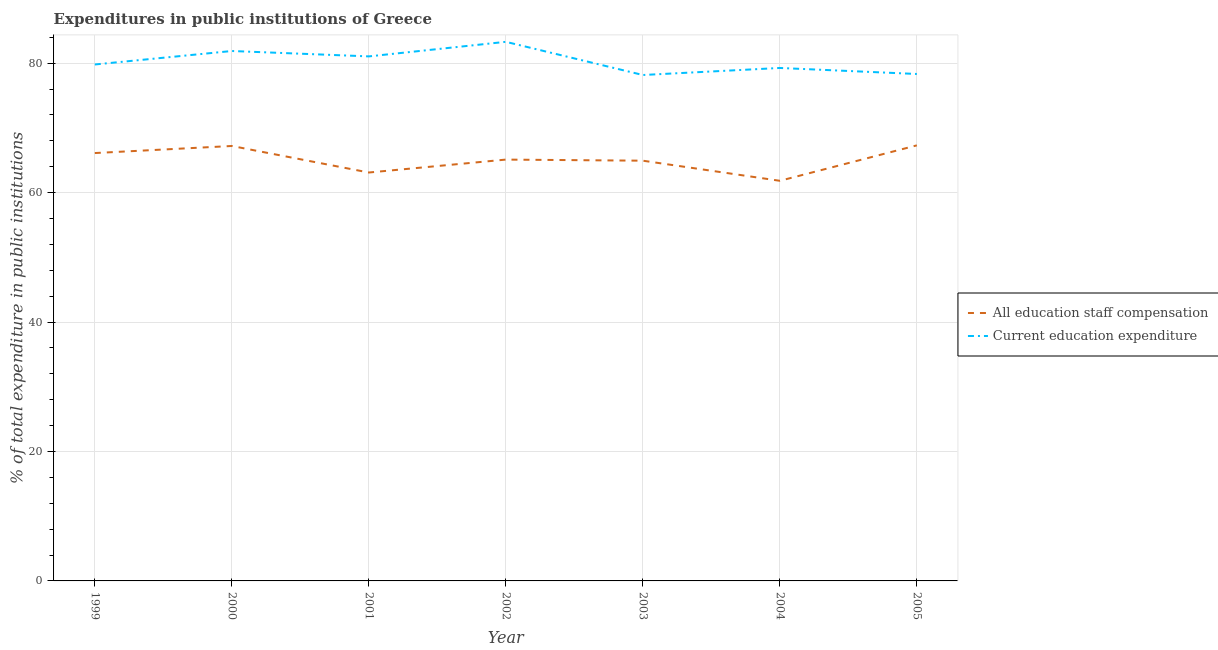Does the line corresponding to expenditure in staff compensation intersect with the line corresponding to expenditure in education?
Provide a short and direct response. No. What is the expenditure in education in 1999?
Ensure brevity in your answer.  79.79. Across all years, what is the maximum expenditure in staff compensation?
Provide a short and direct response. 67.29. Across all years, what is the minimum expenditure in education?
Your answer should be very brief. 78.16. In which year was the expenditure in staff compensation maximum?
Offer a very short reply. 2005. In which year was the expenditure in staff compensation minimum?
Offer a very short reply. 2004. What is the total expenditure in staff compensation in the graph?
Provide a short and direct response. 455.54. What is the difference between the expenditure in education in 2002 and that in 2004?
Offer a very short reply. 4.04. What is the difference between the expenditure in education in 2004 and the expenditure in staff compensation in 2005?
Ensure brevity in your answer.  11.96. What is the average expenditure in education per year?
Keep it short and to the point. 80.25. In the year 2000, what is the difference between the expenditure in education and expenditure in staff compensation?
Your response must be concise. 14.67. In how many years, is the expenditure in staff compensation greater than 64 %?
Make the answer very short. 5. What is the ratio of the expenditure in staff compensation in 1999 to that in 2002?
Your answer should be very brief. 1.02. Is the expenditure in education in 1999 less than that in 2004?
Your answer should be compact. No. What is the difference between the highest and the second highest expenditure in education?
Provide a succinct answer. 1.42. What is the difference between the highest and the lowest expenditure in staff compensation?
Ensure brevity in your answer.  5.48. Is the expenditure in staff compensation strictly greater than the expenditure in education over the years?
Make the answer very short. No. How many lines are there?
Your response must be concise. 2. How many years are there in the graph?
Provide a succinct answer. 7. Are the values on the major ticks of Y-axis written in scientific E-notation?
Your answer should be compact. No. Where does the legend appear in the graph?
Ensure brevity in your answer.  Center right. What is the title of the graph?
Provide a succinct answer. Expenditures in public institutions of Greece. What is the label or title of the Y-axis?
Your answer should be compact. % of total expenditure in public institutions. What is the % of total expenditure in public institutions in All education staff compensation in 1999?
Offer a very short reply. 66.11. What is the % of total expenditure in public institutions in Current education expenditure in 1999?
Give a very brief answer. 79.79. What is the % of total expenditure in public institutions in All education staff compensation in 2000?
Your response must be concise. 67.2. What is the % of total expenditure in public institutions of Current education expenditure in 2000?
Offer a terse response. 81.87. What is the % of total expenditure in public institutions of All education staff compensation in 2001?
Give a very brief answer. 63.1. What is the % of total expenditure in public institutions in Current education expenditure in 2001?
Make the answer very short. 81.04. What is the % of total expenditure in public institutions of All education staff compensation in 2002?
Provide a succinct answer. 65.1. What is the % of total expenditure in public institutions of Current education expenditure in 2002?
Provide a succinct answer. 83.29. What is the % of total expenditure in public institutions in All education staff compensation in 2003?
Give a very brief answer. 64.93. What is the % of total expenditure in public institutions in Current education expenditure in 2003?
Provide a succinct answer. 78.16. What is the % of total expenditure in public institutions of All education staff compensation in 2004?
Your answer should be very brief. 61.82. What is the % of total expenditure in public institutions of Current education expenditure in 2004?
Offer a very short reply. 79.25. What is the % of total expenditure in public institutions in All education staff compensation in 2005?
Offer a terse response. 67.29. What is the % of total expenditure in public institutions in Current education expenditure in 2005?
Provide a succinct answer. 78.32. Across all years, what is the maximum % of total expenditure in public institutions of All education staff compensation?
Your answer should be very brief. 67.29. Across all years, what is the maximum % of total expenditure in public institutions of Current education expenditure?
Keep it short and to the point. 83.29. Across all years, what is the minimum % of total expenditure in public institutions in All education staff compensation?
Keep it short and to the point. 61.82. Across all years, what is the minimum % of total expenditure in public institutions in Current education expenditure?
Ensure brevity in your answer.  78.16. What is the total % of total expenditure in public institutions in All education staff compensation in the graph?
Make the answer very short. 455.54. What is the total % of total expenditure in public institutions in Current education expenditure in the graph?
Your answer should be compact. 561.73. What is the difference between the % of total expenditure in public institutions of All education staff compensation in 1999 and that in 2000?
Offer a very short reply. -1.09. What is the difference between the % of total expenditure in public institutions of Current education expenditure in 1999 and that in 2000?
Provide a short and direct response. -2.08. What is the difference between the % of total expenditure in public institutions in All education staff compensation in 1999 and that in 2001?
Ensure brevity in your answer.  3.01. What is the difference between the % of total expenditure in public institutions in Current education expenditure in 1999 and that in 2001?
Keep it short and to the point. -1.25. What is the difference between the % of total expenditure in public institutions of All education staff compensation in 1999 and that in 2002?
Offer a terse response. 1.01. What is the difference between the % of total expenditure in public institutions in Current education expenditure in 1999 and that in 2002?
Offer a very short reply. -3.5. What is the difference between the % of total expenditure in public institutions in All education staff compensation in 1999 and that in 2003?
Ensure brevity in your answer.  1.18. What is the difference between the % of total expenditure in public institutions of Current education expenditure in 1999 and that in 2003?
Your response must be concise. 1.63. What is the difference between the % of total expenditure in public institutions in All education staff compensation in 1999 and that in 2004?
Provide a short and direct response. 4.29. What is the difference between the % of total expenditure in public institutions in Current education expenditure in 1999 and that in 2004?
Offer a terse response. 0.54. What is the difference between the % of total expenditure in public institutions of All education staff compensation in 1999 and that in 2005?
Ensure brevity in your answer.  -1.19. What is the difference between the % of total expenditure in public institutions of Current education expenditure in 1999 and that in 2005?
Your answer should be very brief. 1.47. What is the difference between the % of total expenditure in public institutions in All education staff compensation in 2000 and that in 2001?
Provide a succinct answer. 4.1. What is the difference between the % of total expenditure in public institutions in Current education expenditure in 2000 and that in 2001?
Your answer should be compact. 0.83. What is the difference between the % of total expenditure in public institutions in All education staff compensation in 2000 and that in 2002?
Offer a terse response. 2.1. What is the difference between the % of total expenditure in public institutions in Current education expenditure in 2000 and that in 2002?
Offer a terse response. -1.42. What is the difference between the % of total expenditure in public institutions of All education staff compensation in 2000 and that in 2003?
Your answer should be very brief. 2.27. What is the difference between the % of total expenditure in public institutions of Current education expenditure in 2000 and that in 2003?
Your response must be concise. 3.71. What is the difference between the % of total expenditure in public institutions of All education staff compensation in 2000 and that in 2004?
Give a very brief answer. 5.38. What is the difference between the % of total expenditure in public institutions in Current education expenditure in 2000 and that in 2004?
Offer a terse response. 2.62. What is the difference between the % of total expenditure in public institutions in All education staff compensation in 2000 and that in 2005?
Your response must be concise. -0.1. What is the difference between the % of total expenditure in public institutions in Current education expenditure in 2000 and that in 2005?
Offer a terse response. 3.55. What is the difference between the % of total expenditure in public institutions in All education staff compensation in 2001 and that in 2002?
Offer a terse response. -2. What is the difference between the % of total expenditure in public institutions in Current education expenditure in 2001 and that in 2002?
Offer a terse response. -2.25. What is the difference between the % of total expenditure in public institutions of All education staff compensation in 2001 and that in 2003?
Your answer should be very brief. -1.83. What is the difference between the % of total expenditure in public institutions of Current education expenditure in 2001 and that in 2003?
Make the answer very short. 2.88. What is the difference between the % of total expenditure in public institutions in All education staff compensation in 2001 and that in 2004?
Your response must be concise. 1.28. What is the difference between the % of total expenditure in public institutions of Current education expenditure in 2001 and that in 2004?
Give a very brief answer. 1.79. What is the difference between the % of total expenditure in public institutions in All education staff compensation in 2001 and that in 2005?
Provide a short and direct response. -4.2. What is the difference between the % of total expenditure in public institutions in Current education expenditure in 2001 and that in 2005?
Provide a succinct answer. 2.72. What is the difference between the % of total expenditure in public institutions of All education staff compensation in 2002 and that in 2003?
Your answer should be very brief. 0.17. What is the difference between the % of total expenditure in public institutions in Current education expenditure in 2002 and that in 2003?
Ensure brevity in your answer.  5.13. What is the difference between the % of total expenditure in public institutions of All education staff compensation in 2002 and that in 2004?
Ensure brevity in your answer.  3.28. What is the difference between the % of total expenditure in public institutions of Current education expenditure in 2002 and that in 2004?
Ensure brevity in your answer.  4.04. What is the difference between the % of total expenditure in public institutions in All education staff compensation in 2002 and that in 2005?
Keep it short and to the point. -2.2. What is the difference between the % of total expenditure in public institutions in Current education expenditure in 2002 and that in 2005?
Ensure brevity in your answer.  4.97. What is the difference between the % of total expenditure in public institutions in All education staff compensation in 2003 and that in 2004?
Make the answer very short. 3.11. What is the difference between the % of total expenditure in public institutions in Current education expenditure in 2003 and that in 2004?
Your answer should be compact. -1.09. What is the difference between the % of total expenditure in public institutions of All education staff compensation in 2003 and that in 2005?
Offer a terse response. -2.37. What is the difference between the % of total expenditure in public institutions of Current education expenditure in 2003 and that in 2005?
Give a very brief answer. -0.16. What is the difference between the % of total expenditure in public institutions of All education staff compensation in 2004 and that in 2005?
Keep it short and to the point. -5.47. What is the difference between the % of total expenditure in public institutions in Current education expenditure in 2004 and that in 2005?
Ensure brevity in your answer.  0.93. What is the difference between the % of total expenditure in public institutions of All education staff compensation in 1999 and the % of total expenditure in public institutions of Current education expenditure in 2000?
Your answer should be compact. -15.77. What is the difference between the % of total expenditure in public institutions in All education staff compensation in 1999 and the % of total expenditure in public institutions in Current education expenditure in 2001?
Make the answer very short. -14.93. What is the difference between the % of total expenditure in public institutions of All education staff compensation in 1999 and the % of total expenditure in public institutions of Current education expenditure in 2002?
Your answer should be compact. -17.18. What is the difference between the % of total expenditure in public institutions in All education staff compensation in 1999 and the % of total expenditure in public institutions in Current education expenditure in 2003?
Provide a short and direct response. -12.06. What is the difference between the % of total expenditure in public institutions of All education staff compensation in 1999 and the % of total expenditure in public institutions of Current education expenditure in 2004?
Make the answer very short. -13.15. What is the difference between the % of total expenditure in public institutions in All education staff compensation in 1999 and the % of total expenditure in public institutions in Current education expenditure in 2005?
Make the answer very short. -12.22. What is the difference between the % of total expenditure in public institutions in All education staff compensation in 2000 and the % of total expenditure in public institutions in Current education expenditure in 2001?
Offer a terse response. -13.84. What is the difference between the % of total expenditure in public institutions of All education staff compensation in 2000 and the % of total expenditure in public institutions of Current education expenditure in 2002?
Offer a terse response. -16.09. What is the difference between the % of total expenditure in public institutions of All education staff compensation in 2000 and the % of total expenditure in public institutions of Current education expenditure in 2003?
Keep it short and to the point. -10.97. What is the difference between the % of total expenditure in public institutions in All education staff compensation in 2000 and the % of total expenditure in public institutions in Current education expenditure in 2004?
Offer a very short reply. -12.05. What is the difference between the % of total expenditure in public institutions of All education staff compensation in 2000 and the % of total expenditure in public institutions of Current education expenditure in 2005?
Provide a short and direct response. -11.12. What is the difference between the % of total expenditure in public institutions of All education staff compensation in 2001 and the % of total expenditure in public institutions of Current education expenditure in 2002?
Give a very brief answer. -20.19. What is the difference between the % of total expenditure in public institutions in All education staff compensation in 2001 and the % of total expenditure in public institutions in Current education expenditure in 2003?
Make the answer very short. -15.07. What is the difference between the % of total expenditure in public institutions in All education staff compensation in 2001 and the % of total expenditure in public institutions in Current education expenditure in 2004?
Your answer should be very brief. -16.15. What is the difference between the % of total expenditure in public institutions of All education staff compensation in 2001 and the % of total expenditure in public institutions of Current education expenditure in 2005?
Your response must be concise. -15.22. What is the difference between the % of total expenditure in public institutions in All education staff compensation in 2002 and the % of total expenditure in public institutions in Current education expenditure in 2003?
Give a very brief answer. -13.07. What is the difference between the % of total expenditure in public institutions of All education staff compensation in 2002 and the % of total expenditure in public institutions of Current education expenditure in 2004?
Your answer should be compact. -14.16. What is the difference between the % of total expenditure in public institutions in All education staff compensation in 2002 and the % of total expenditure in public institutions in Current education expenditure in 2005?
Your answer should be very brief. -13.23. What is the difference between the % of total expenditure in public institutions of All education staff compensation in 2003 and the % of total expenditure in public institutions of Current education expenditure in 2004?
Your answer should be compact. -14.33. What is the difference between the % of total expenditure in public institutions of All education staff compensation in 2003 and the % of total expenditure in public institutions of Current education expenditure in 2005?
Offer a terse response. -13.4. What is the difference between the % of total expenditure in public institutions in All education staff compensation in 2004 and the % of total expenditure in public institutions in Current education expenditure in 2005?
Provide a succinct answer. -16.5. What is the average % of total expenditure in public institutions in All education staff compensation per year?
Provide a succinct answer. 65.08. What is the average % of total expenditure in public institutions of Current education expenditure per year?
Keep it short and to the point. 80.25. In the year 1999, what is the difference between the % of total expenditure in public institutions of All education staff compensation and % of total expenditure in public institutions of Current education expenditure?
Offer a very short reply. -13.68. In the year 2000, what is the difference between the % of total expenditure in public institutions in All education staff compensation and % of total expenditure in public institutions in Current education expenditure?
Your answer should be compact. -14.67. In the year 2001, what is the difference between the % of total expenditure in public institutions in All education staff compensation and % of total expenditure in public institutions in Current education expenditure?
Your answer should be very brief. -17.94. In the year 2002, what is the difference between the % of total expenditure in public institutions of All education staff compensation and % of total expenditure in public institutions of Current education expenditure?
Provide a short and direct response. -18.19. In the year 2003, what is the difference between the % of total expenditure in public institutions in All education staff compensation and % of total expenditure in public institutions in Current education expenditure?
Provide a succinct answer. -13.24. In the year 2004, what is the difference between the % of total expenditure in public institutions in All education staff compensation and % of total expenditure in public institutions in Current education expenditure?
Your answer should be compact. -17.43. In the year 2005, what is the difference between the % of total expenditure in public institutions of All education staff compensation and % of total expenditure in public institutions of Current education expenditure?
Your response must be concise. -11.03. What is the ratio of the % of total expenditure in public institutions in All education staff compensation in 1999 to that in 2000?
Make the answer very short. 0.98. What is the ratio of the % of total expenditure in public institutions of Current education expenditure in 1999 to that in 2000?
Make the answer very short. 0.97. What is the ratio of the % of total expenditure in public institutions in All education staff compensation in 1999 to that in 2001?
Provide a succinct answer. 1.05. What is the ratio of the % of total expenditure in public institutions in Current education expenditure in 1999 to that in 2001?
Provide a short and direct response. 0.98. What is the ratio of the % of total expenditure in public institutions in All education staff compensation in 1999 to that in 2002?
Your response must be concise. 1.02. What is the ratio of the % of total expenditure in public institutions in Current education expenditure in 1999 to that in 2002?
Provide a short and direct response. 0.96. What is the ratio of the % of total expenditure in public institutions in All education staff compensation in 1999 to that in 2003?
Provide a succinct answer. 1.02. What is the ratio of the % of total expenditure in public institutions of Current education expenditure in 1999 to that in 2003?
Provide a succinct answer. 1.02. What is the ratio of the % of total expenditure in public institutions of All education staff compensation in 1999 to that in 2004?
Provide a succinct answer. 1.07. What is the ratio of the % of total expenditure in public institutions in Current education expenditure in 1999 to that in 2004?
Give a very brief answer. 1.01. What is the ratio of the % of total expenditure in public institutions of All education staff compensation in 1999 to that in 2005?
Provide a short and direct response. 0.98. What is the ratio of the % of total expenditure in public institutions in Current education expenditure in 1999 to that in 2005?
Give a very brief answer. 1.02. What is the ratio of the % of total expenditure in public institutions of All education staff compensation in 2000 to that in 2001?
Your answer should be compact. 1.06. What is the ratio of the % of total expenditure in public institutions in Current education expenditure in 2000 to that in 2001?
Make the answer very short. 1.01. What is the ratio of the % of total expenditure in public institutions of All education staff compensation in 2000 to that in 2002?
Your answer should be compact. 1.03. What is the ratio of the % of total expenditure in public institutions of Current education expenditure in 2000 to that in 2002?
Your answer should be compact. 0.98. What is the ratio of the % of total expenditure in public institutions in All education staff compensation in 2000 to that in 2003?
Provide a short and direct response. 1.03. What is the ratio of the % of total expenditure in public institutions in Current education expenditure in 2000 to that in 2003?
Make the answer very short. 1.05. What is the ratio of the % of total expenditure in public institutions of All education staff compensation in 2000 to that in 2004?
Offer a very short reply. 1.09. What is the ratio of the % of total expenditure in public institutions in Current education expenditure in 2000 to that in 2004?
Provide a succinct answer. 1.03. What is the ratio of the % of total expenditure in public institutions in Current education expenditure in 2000 to that in 2005?
Provide a succinct answer. 1.05. What is the ratio of the % of total expenditure in public institutions of All education staff compensation in 2001 to that in 2002?
Provide a short and direct response. 0.97. What is the ratio of the % of total expenditure in public institutions of Current education expenditure in 2001 to that in 2002?
Give a very brief answer. 0.97. What is the ratio of the % of total expenditure in public institutions of All education staff compensation in 2001 to that in 2003?
Your answer should be compact. 0.97. What is the ratio of the % of total expenditure in public institutions of Current education expenditure in 2001 to that in 2003?
Keep it short and to the point. 1.04. What is the ratio of the % of total expenditure in public institutions of All education staff compensation in 2001 to that in 2004?
Ensure brevity in your answer.  1.02. What is the ratio of the % of total expenditure in public institutions in Current education expenditure in 2001 to that in 2004?
Give a very brief answer. 1.02. What is the ratio of the % of total expenditure in public institutions in All education staff compensation in 2001 to that in 2005?
Provide a succinct answer. 0.94. What is the ratio of the % of total expenditure in public institutions in Current education expenditure in 2001 to that in 2005?
Your response must be concise. 1.03. What is the ratio of the % of total expenditure in public institutions in Current education expenditure in 2002 to that in 2003?
Your answer should be compact. 1.07. What is the ratio of the % of total expenditure in public institutions in All education staff compensation in 2002 to that in 2004?
Give a very brief answer. 1.05. What is the ratio of the % of total expenditure in public institutions of Current education expenditure in 2002 to that in 2004?
Your answer should be compact. 1.05. What is the ratio of the % of total expenditure in public institutions in All education staff compensation in 2002 to that in 2005?
Provide a succinct answer. 0.97. What is the ratio of the % of total expenditure in public institutions of Current education expenditure in 2002 to that in 2005?
Make the answer very short. 1.06. What is the ratio of the % of total expenditure in public institutions of All education staff compensation in 2003 to that in 2004?
Your response must be concise. 1.05. What is the ratio of the % of total expenditure in public institutions in Current education expenditure in 2003 to that in 2004?
Keep it short and to the point. 0.99. What is the ratio of the % of total expenditure in public institutions of All education staff compensation in 2003 to that in 2005?
Your response must be concise. 0.96. What is the ratio of the % of total expenditure in public institutions of Current education expenditure in 2003 to that in 2005?
Your answer should be compact. 1. What is the ratio of the % of total expenditure in public institutions of All education staff compensation in 2004 to that in 2005?
Your answer should be very brief. 0.92. What is the ratio of the % of total expenditure in public institutions of Current education expenditure in 2004 to that in 2005?
Your response must be concise. 1.01. What is the difference between the highest and the second highest % of total expenditure in public institutions of All education staff compensation?
Offer a very short reply. 0.1. What is the difference between the highest and the second highest % of total expenditure in public institutions of Current education expenditure?
Provide a succinct answer. 1.42. What is the difference between the highest and the lowest % of total expenditure in public institutions of All education staff compensation?
Ensure brevity in your answer.  5.47. What is the difference between the highest and the lowest % of total expenditure in public institutions of Current education expenditure?
Provide a succinct answer. 5.13. 